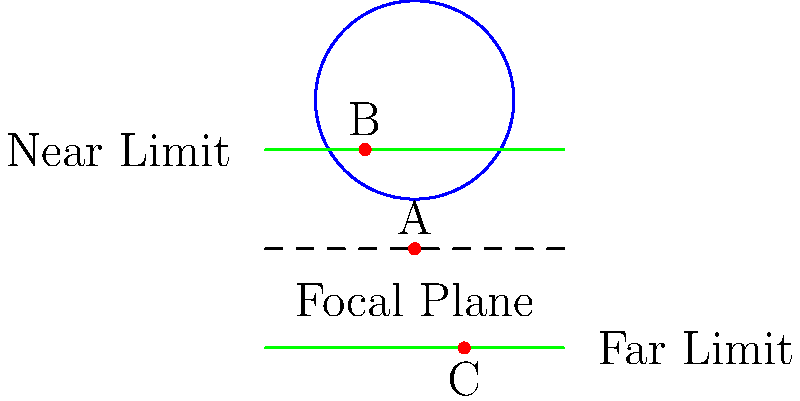In the opening tracking shot of "Touch of Evil," Orson Welles masterfully uses depth of field to create tension. Based on the lens diagram, which object(s) would be in sharp focus if Welles set his focus on point A? To answer this question, we need to understand depth of field and how it's represented in the diagram:

1. The blue circle represents the camera lens.
2. The dashed line is the focal plane, where point A is located.
3. The green lines represent the near and far limits of the depth of field.
4. Points B and C are other objects in the scene.

Step-by-step analysis:
1. When a camera is focused on a point (in this case, A), that point will be on the focal plane and in sharp focus.
2. The depth of field extends from the near limit to the far limit around the focal plane.
3. Any object within this range will appear reasonably sharp.
4. Point A is on the focal plane, so it will be in sharp focus.
5. Point B is outside the depth of field (above the near limit), so it will be out of focus.
6. Point C is within the depth of field (between the near and far limits), so it will appear reasonably sharp.

In "Touch of Evil," Welles often used deep focus techniques to keep multiple planes in focus simultaneously, creating a sense of depth and allowing the audience to observe multiple elements in the frame.
Answer: Objects A and C 